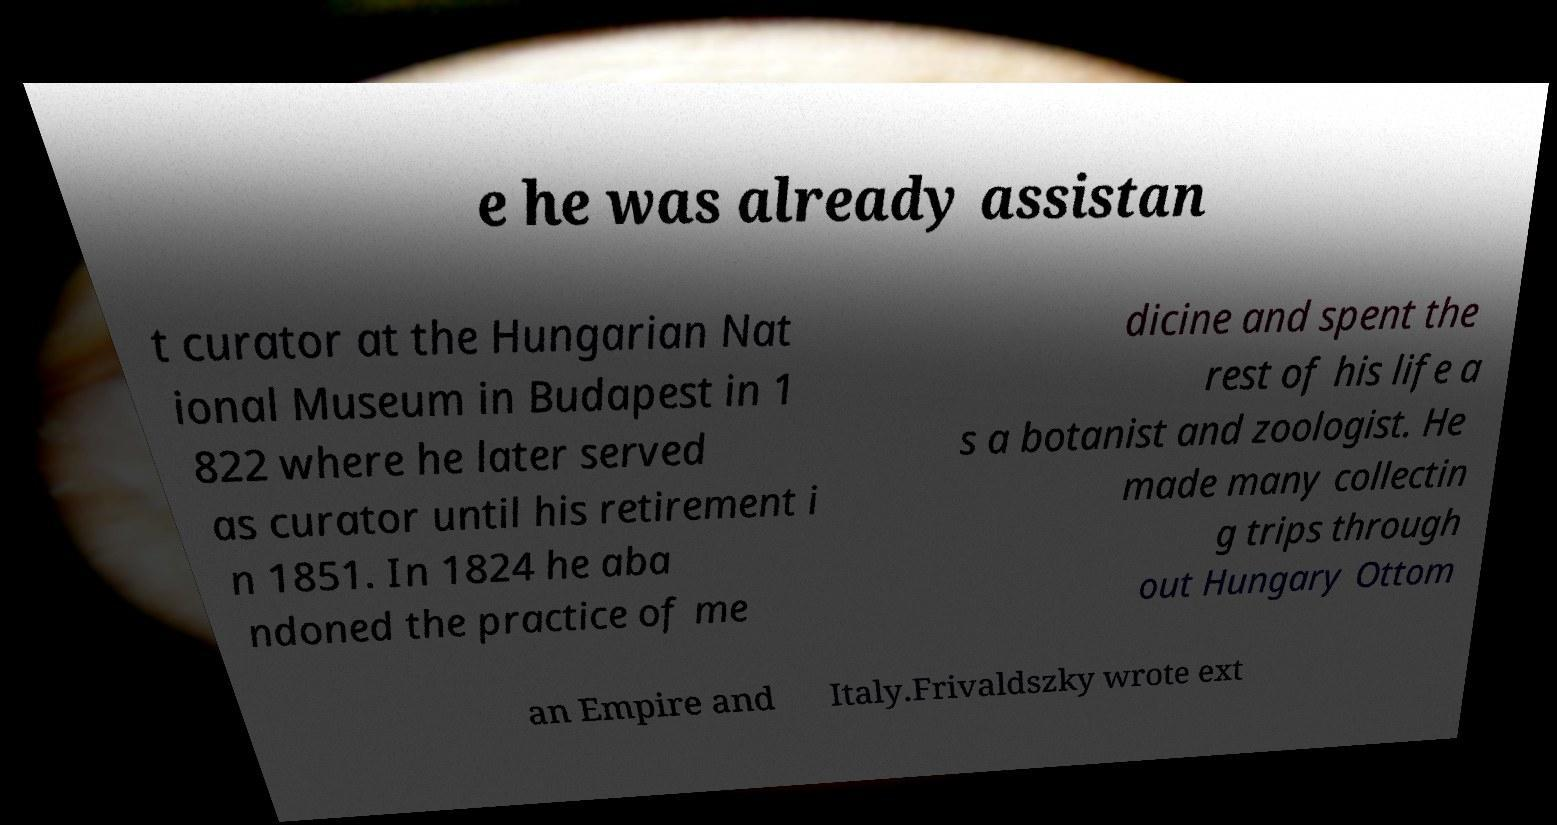Could you assist in decoding the text presented in this image and type it out clearly? e he was already assistan t curator at the Hungarian Nat ional Museum in Budapest in 1 822 where he later served as curator until his retirement i n 1851. In 1824 he aba ndoned the practice of me dicine and spent the rest of his life a s a botanist and zoologist. He made many collectin g trips through out Hungary Ottom an Empire and Italy.Frivaldszky wrote ext 